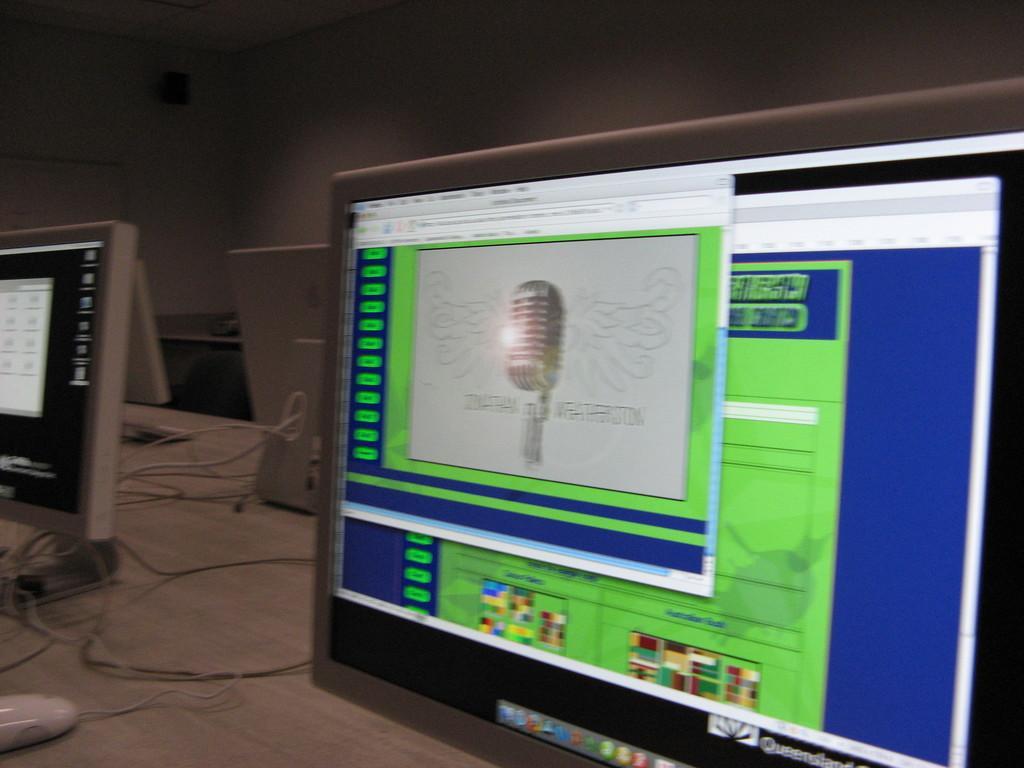Please provide a concise description of this image. Here we can see monitors, mouse, and cables. In the background we can see wall. 